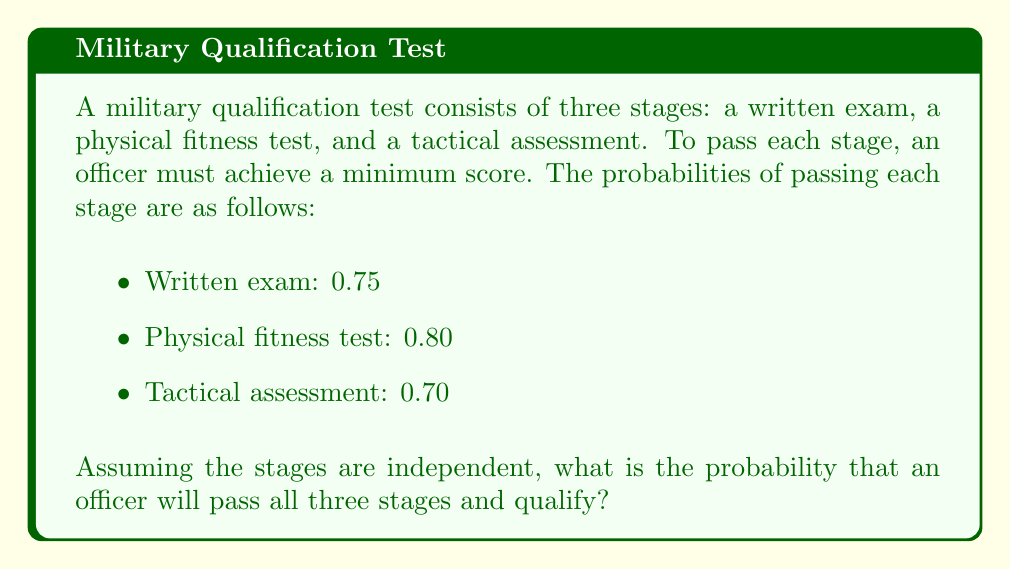Teach me how to tackle this problem. To solve this problem, we need to use the concept of independent events in probability theory. When events are independent, the probability of all events occurring is the product of their individual probabilities.

Let's define the events:
$A$ = passing the written exam
$B$ = passing the physical fitness test
$C$ = passing the tactical assessment

We are given:
$P(A) = 0.75$
$P(B) = 0.80$
$P(C) = 0.70$

To find the probability of passing all three stages, we need to calculate:

$P(A \cap B \cap C) = P(A) \times P(B) \times P(C)$

Substituting the values:

$P(A \cap B \cap C) = 0.75 \times 0.80 \times 0.70$

$P(A \cap B \cap C) = 0.42$

Therefore, the probability of an officer passing all three stages and qualifying is 0.42 or 42%.
Answer: 0.42 or 42% 